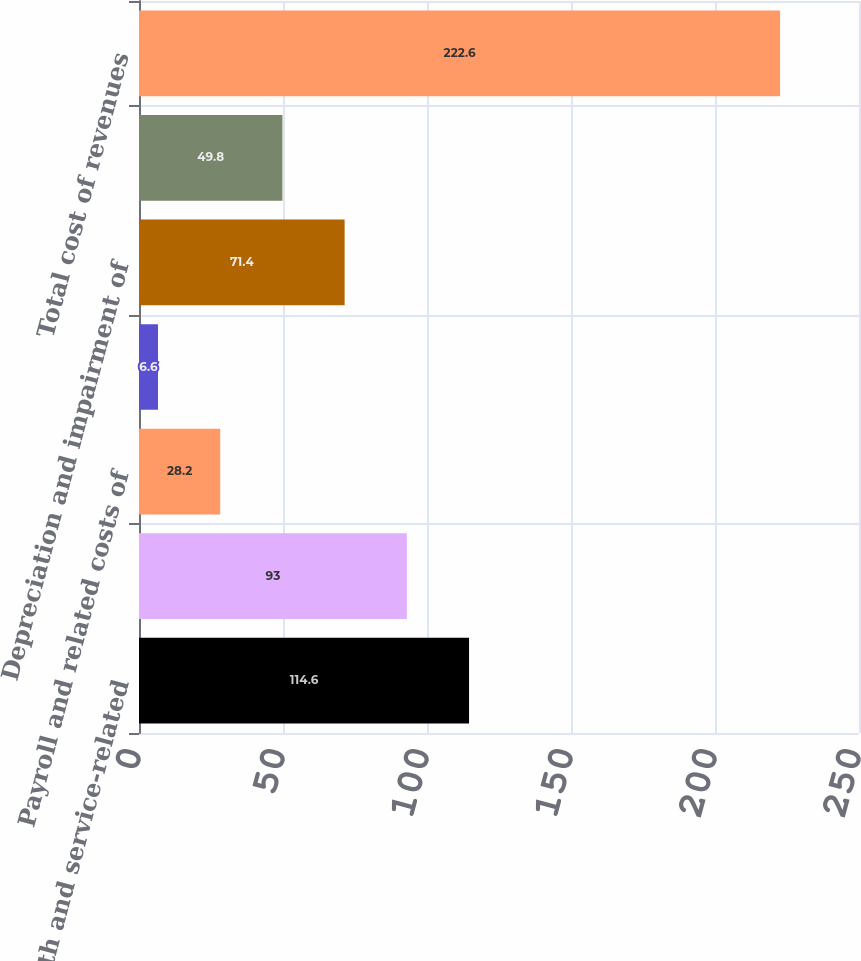<chart> <loc_0><loc_0><loc_500><loc_500><bar_chart><fcel>Bandwidth and service-related<fcel>Co-location fees<fcel>Payroll and related costs of<fcel>Stock-based compensation<fcel>Depreciation and impairment of<fcel>Amortization of internal-use<fcel>Total cost of revenues<nl><fcel>114.6<fcel>93<fcel>28.2<fcel>6.6<fcel>71.4<fcel>49.8<fcel>222.6<nl></chart> 